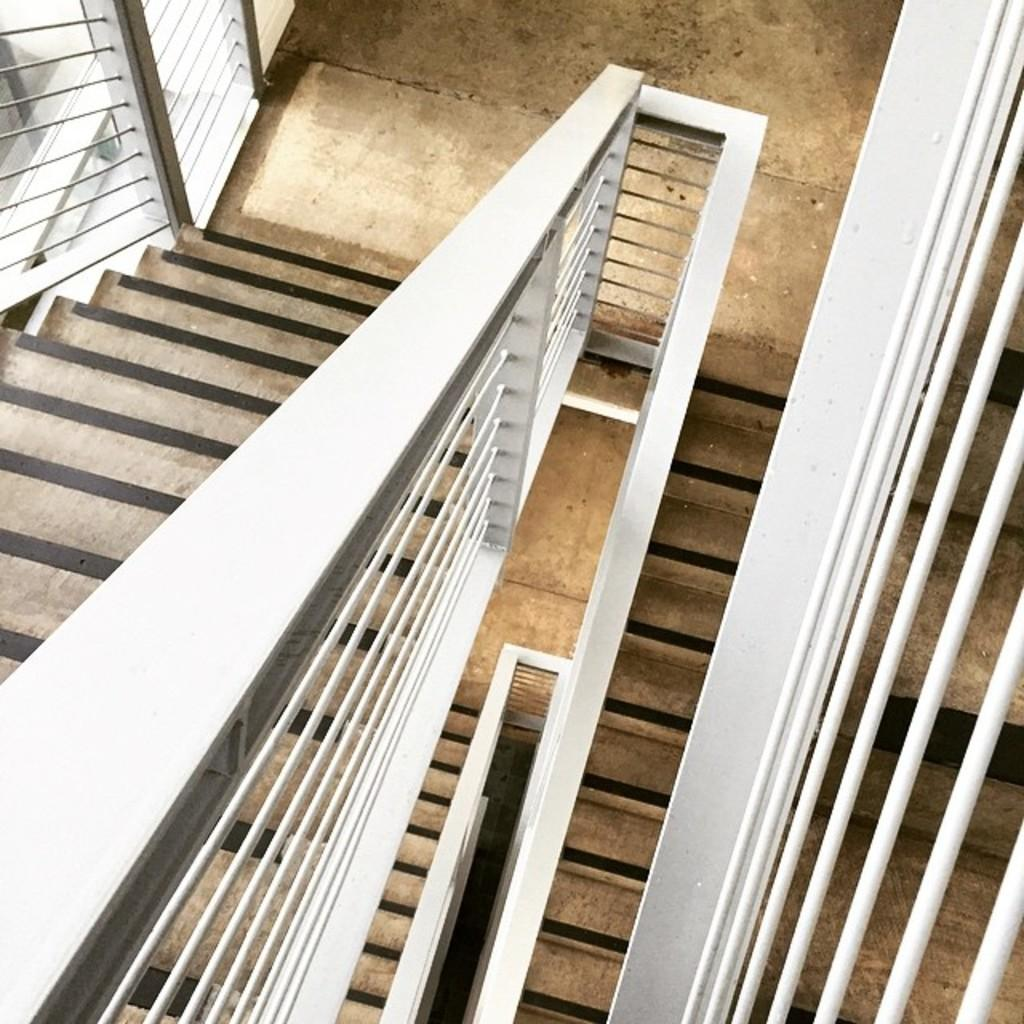Where was the image taken? The image is taken indoors. What can be seen in the right corner of the image? There are metal rods in the right corner of the image. What architectural feature is in the center of the image? There is a staircase in the center of the image. What is used for support and safety alongside the staircase? A handrail is present alongside the staircase. What part of the environment is visible in the image? The ground is visible in the image. What song is being played in the background of the image? There is no indication of any music or sound in the image, so it is not possible to determine what song might be playing. 